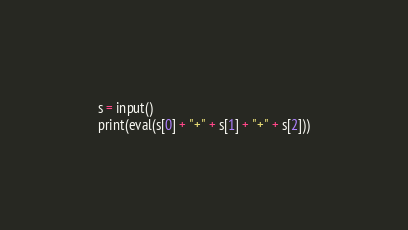<code> <loc_0><loc_0><loc_500><loc_500><_Python_>s = input()
print(eval(s[0] + "+" + s[1] + "+" + s[2]))</code> 